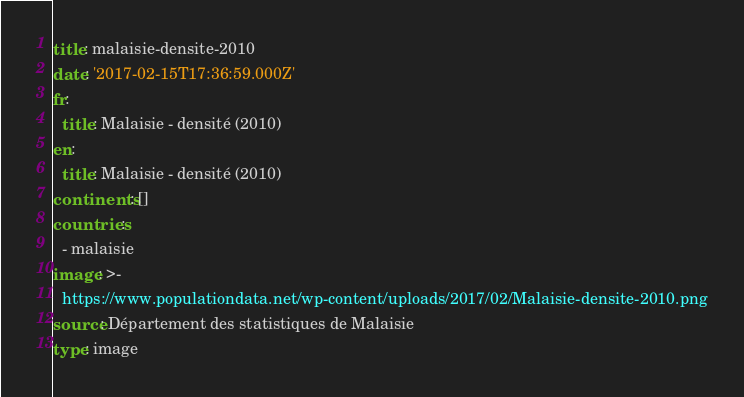Convert code to text. <code><loc_0><loc_0><loc_500><loc_500><_YAML_>title: malaisie-densite-2010
date: '2017-02-15T17:36:59.000Z'
fr:
  title: Malaisie - densité (2010)
en:
  title: Malaisie - densité (2010)
continents: []
countries:
  - malaisie
image: >-
  https://www.populationdata.net/wp-content/uploads/2017/02/Malaisie-densite-2010.png
source: Département des statistiques de Malaisie
type: image
</code> 